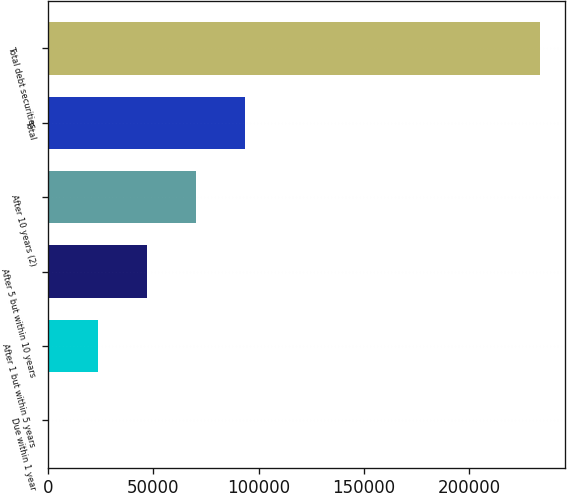Convert chart to OTSL. <chart><loc_0><loc_0><loc_500><loc_500><bar_chart><fcel>Due within 1 year<fcel>After 1 but within 5 years<fcel>After 5 but within 10 years<fcel>After 10 years (2)<fcel>Total<fcel>Total debt securities<nl><fcel>3<fcel>23382<fcel>46761<fcel>70140<fcel>93519<fcel>233793<nl></chart> 